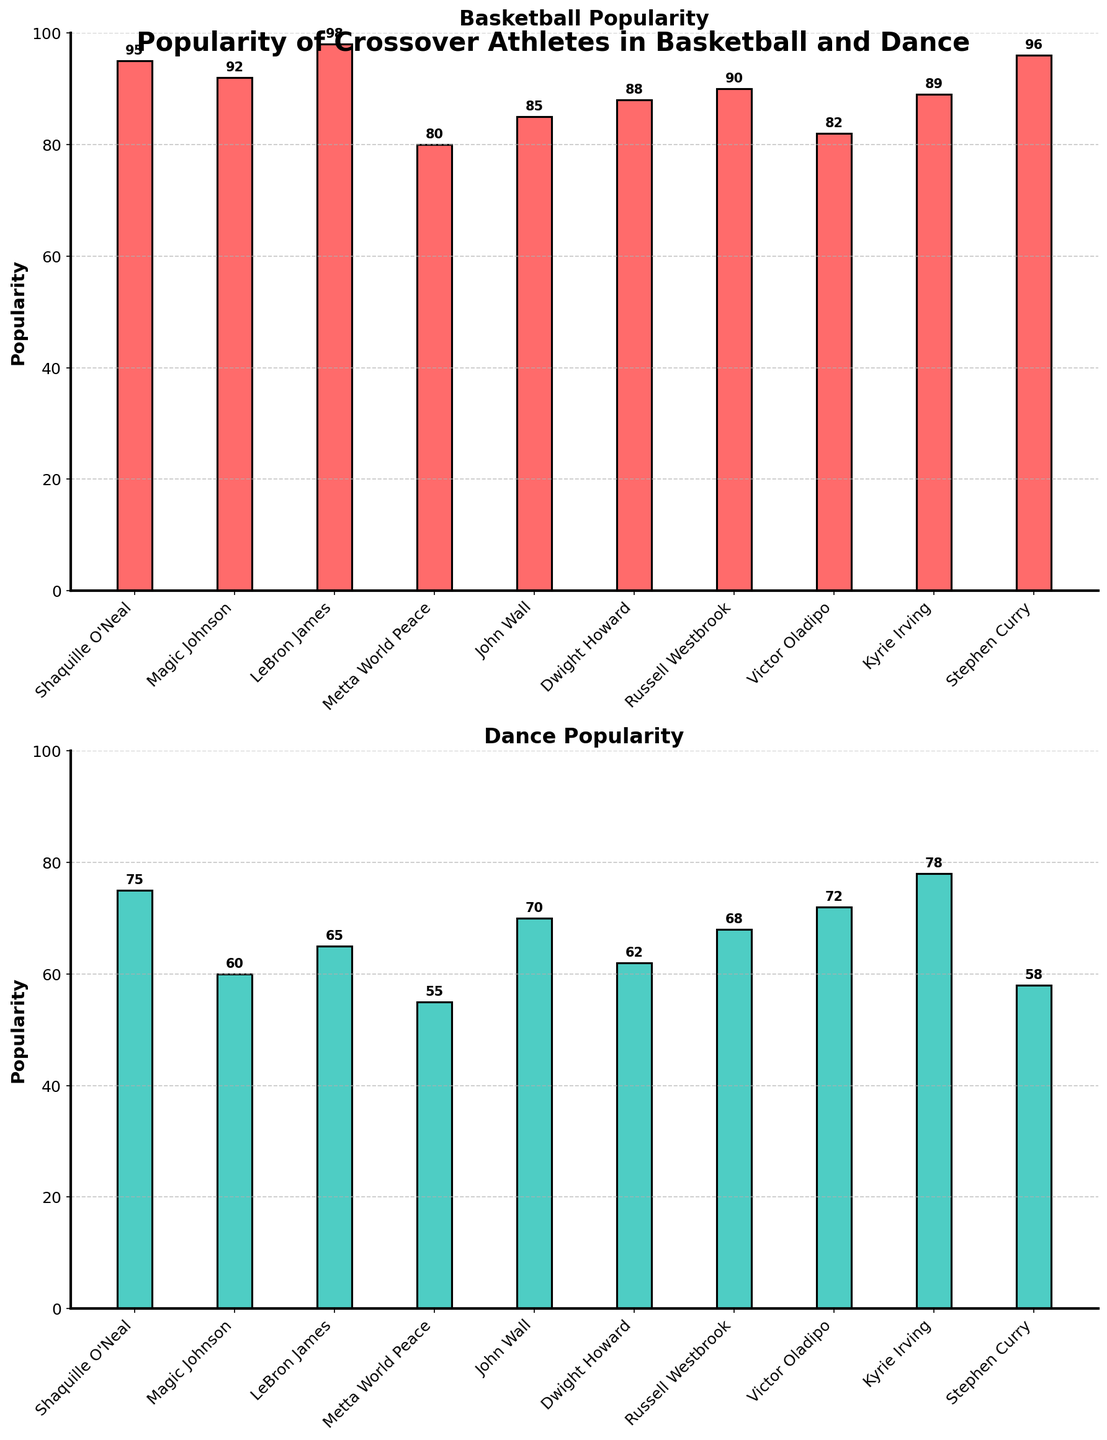Which athlete has the highest popularity in basketball? Look at the bar chart for Basketball Popularity and identify the tallest bar, which corresponds to LeBron James with a popularity score of 98.
Answer: LeBron James Which athlete has the lowest popularity in dance? Look at the bar chart for Dance Popularity and identify the shortest bar, which corresponds to Metta World Peace with a popularity score of 55.
Answer: Metta World Peace Who is more popular in dance: Kyrie Irving or Stephen Curry? Compare the heights of the bars representing Kyrie Irving and Stephen Curry in the Dance Popularity chart. Kyrie Irving has a higher bar with a popularity score of 78 compared to Stephen Curry's 58.
Answer: Kyrie Irving What is the average popularity score for basketball among the listed athletes? Add all basketball popularity scores (95 + 92 + 98 + 80 + 85 + 88 + 90 + 82 + 89 + 96) and divide by the number of athletes, which is 10. The sum is 895, and the average is 895 / 10.
Answer: 89.5 Who has a greater disparity between their basketball and dance popularity, Shaquille O'Neal or John Wall? Calculate the difference between basketball and dance popularity for both athletes: Shaquille O'Neal (95 - 75 = 20) and John Wall (85 - 70 = 15). Shaquille O'Neal has a greater disparity of 20.
Answer: Shaquille O'Neal What is the total combined popularity score in dance for Victor Oladipo and Dwight Howard? Add the dance popularity scores of Victor Oladipo (72) and Dwight Howard (62).
Answer: 134 Which two athletes have the closest popularity scores in basketball? Compare the basketball popularity scores and find the closest pair: Russell Westbrook (90) and Kyrie Irving (89) have the smallest difference of 1.
Answer: Russell Westbrook and Kyrie Irving How many athletes have a dance popularity score greater than 70? Count the number of bars in the Dance Popularity chart that are taller than the corresponding marker for 70: Shaquille O'Neal (75), John Wall (70), Victor Oladipo (72), Kyrie Irving (78).
Answer: 4 What is the difference in average popularity scores between basketball and dance for these athletes? Calculate the average popularity scores for both sports, then find the difference: Basketball average is 89.5, Dance average is (75 + 60 + 65 + 55 + 70 + 62 + 68 + 72 + 78 + 58) / 10 = 66.3. The difference is 89.5 - 66.3.
Answer: 23.2 